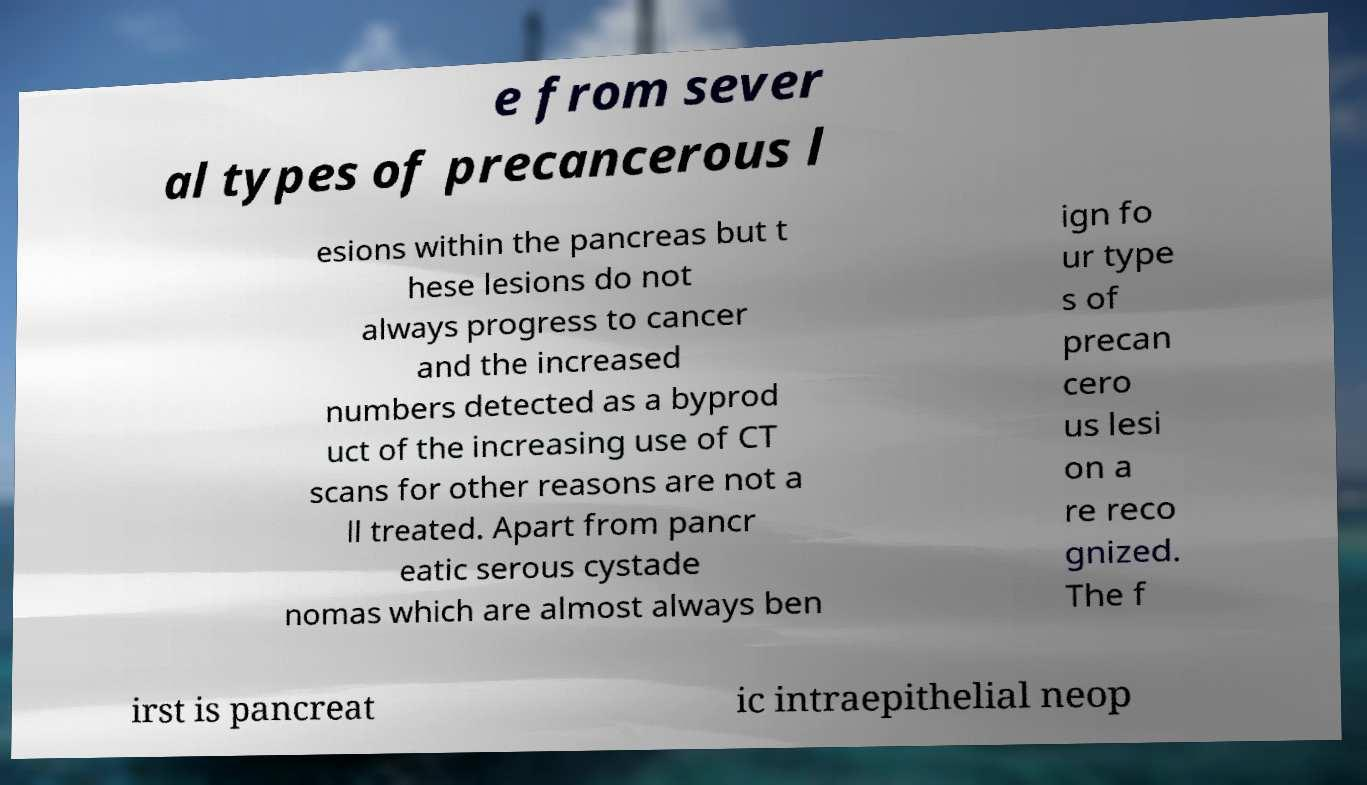Please read and relay the text visible in this image. What does it say? e from sever al types of precancerous l esions within the pancreas but t hese lesions do not always progress to cancer and the increased numbers detected as a byprod uct of the increasing use of CT scans for other reasons are not a ll treated. Apart from pancr eatic serous cystade nomas which are almost always ben ign fo ur type s of precan cero us lesi on a re reco gnized. The f irst is pancreat ic intraepithelial neop 